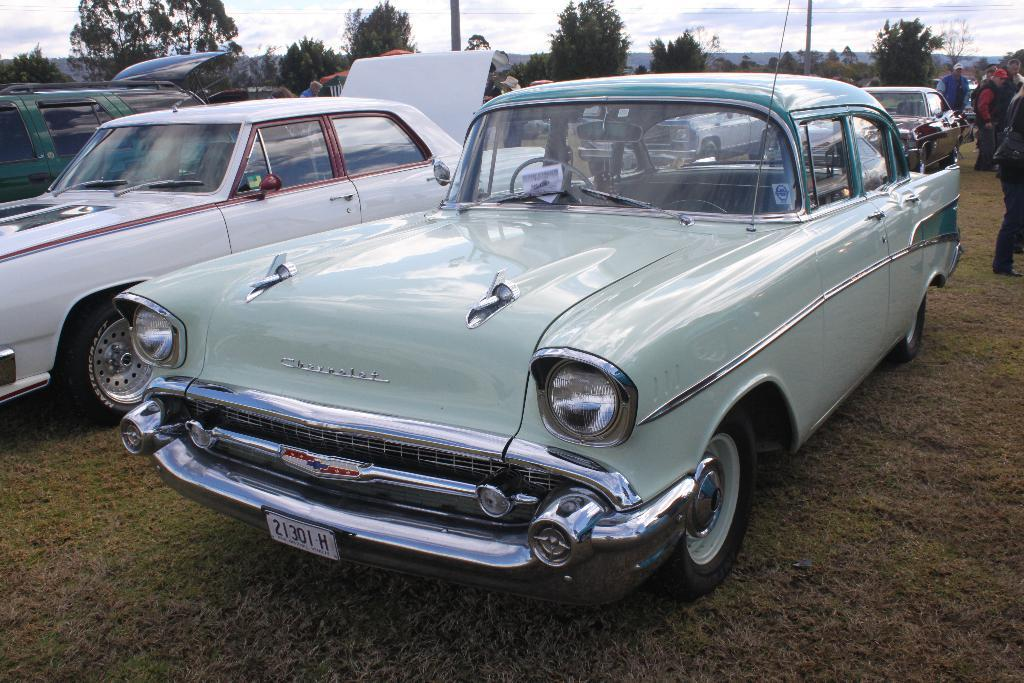What is located on the grass in the image? There are vehicles on the grass in the image. What can be seen in the image besides the vehicles? There is a group of people standing and trees in the image. What type of landscape is visible in the image? There are hills in the image, indicating a hilly landscape. What is visible in the background of the image? The sky is visible in the background of the image. What type of drug is being grown in the cabbage patch in the image? There is no cabbage patch or drug present in the image. What type of oatmeal is being served to the group of people in the image? There is no oatmeal or serving activity present in the image. 